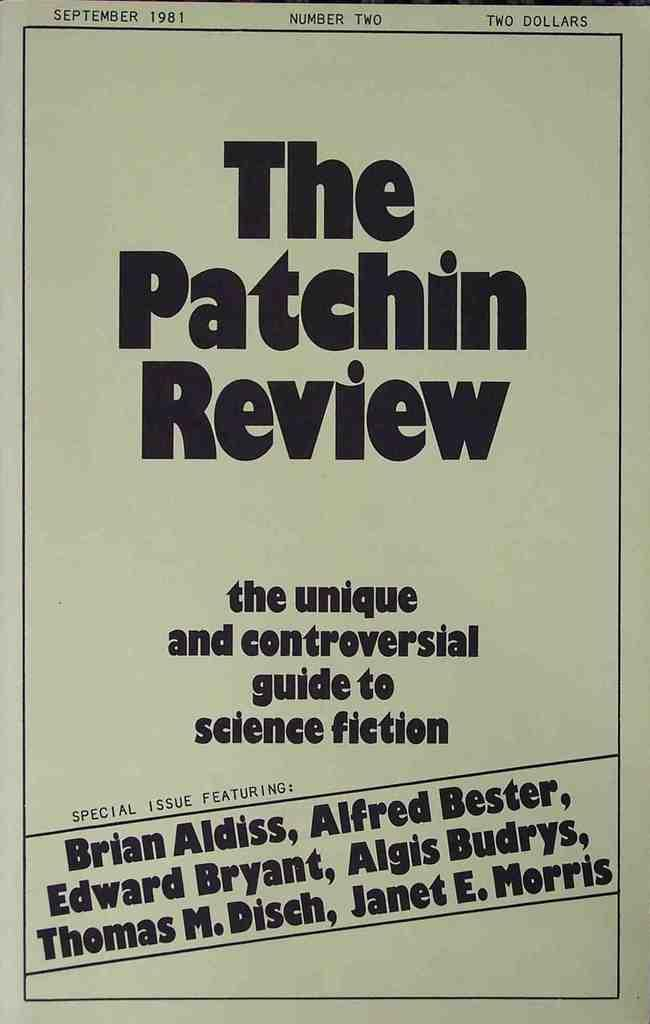<image>
Summarize the visual content of the image. Poster for The Patchin Review featuring "Brian Aldiss". 